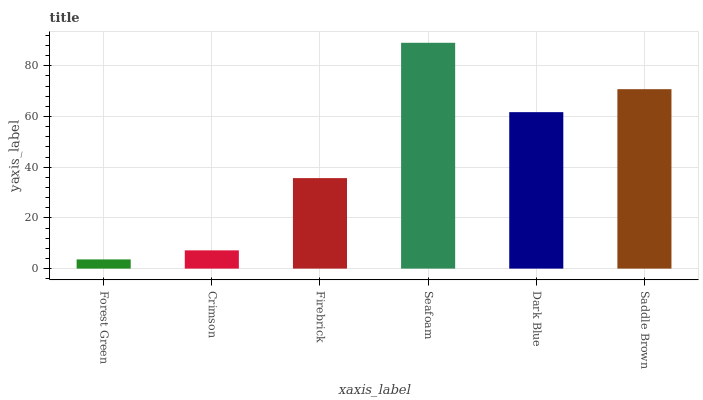Is Forest Green the minimum?
Answer yes or no. Yes. Is Seafoam the maximum?
Answer yes or no. Yes. Is Crimson the minimum?
Answer yes or no. No. Is Crimson the maximum?
Answer yes or no. No. Is Crimson greater than Forest Green?
Answer yes or no. Yes. Is Forest Green less than Crimson?
Answer yes or no. Yes. Is Forest Green greater than Crimson?
Answer yes or no. No. Is Crimson less than Forest Green?
Answer yes or no. No. Is Dark Blue the high median?
Answer yes or no. Yes. Is Firebrick the low median?
Answer yes or no. Yes. Is Seafoam the high median?
Answer yes or no. No. Is Dark Blue the low median?
Answer yes or no. No. 